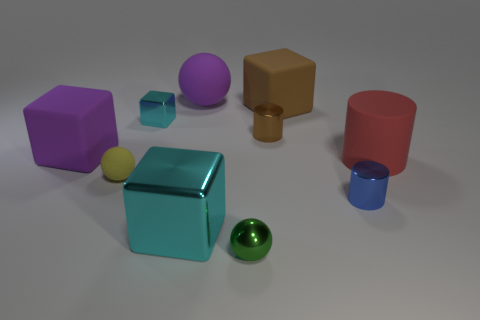Subtract all cubes. How many objects are left? 6 Add 8 metal spheres. How many metal spheres exist? 9 Subtract 1 red cylinders. How many objects are left? 9 Subtract all tiny yellow rubber things. Subtract all large purple objects. How many objects are left? 7 Add 7 tiny cyan cubes. How many tiny cyan cubes are left? 8 